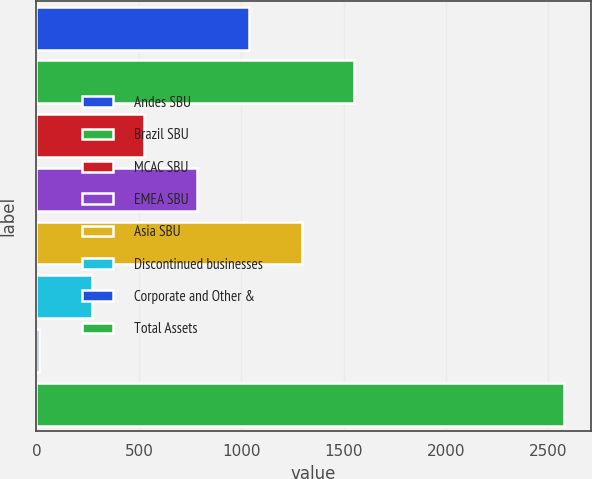<chart> <loc_0><loc_0><loc_500><loc_500><bar_chart><fcel>Andes SBU<fcel>Brazil SBU<fcel>MCAC SBU<fcel>EMEA SBU<fcel>Asia SBU<fcel>Discontinued businesses<fcel>Corporate and Other &<fcel>Total Assets<nl><fcel>1040<fcel>1553<fcel>527<fcel>783.5<fcel>1296.5<fcel>270.5<fcel>14<fcel>2579<nl></chart> 